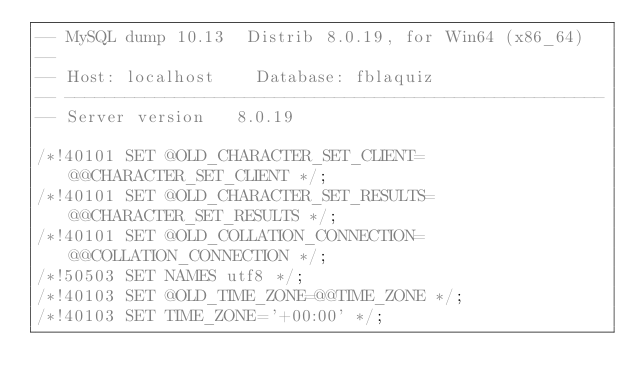Convert code to text. <code><loc_0><loc_0><loc_500><loc_500><_SQL_>-- MySQL dump 10.13  Distrib 8.0.19, for Win64 (x86_64)
--
-- Host: localhost    Database: fblaquiz
-- ------------------------------------------------------
-- Server version	8.0.19

/*!40101 SET @OLD_CHARACTER_SET_CLIENT=@@CHARACTER_SET_CLIENT */;
/*!40101 SET @OLD_CHARACTER_SET_RESULTS=@@CHARACTER_SET_RESULTS */;
/*!40101 SET @OLD_COLLATION_CONNECTION=@@COLLATION_CONNECTION */;
/*!50503 SET NAMES utf8 */;
/*!40103 SET @OLD_TIME_ZONE=@@TIME_ZONE */;
/*!40103 SET TIME_ZONE='+00:00' */;</code> 